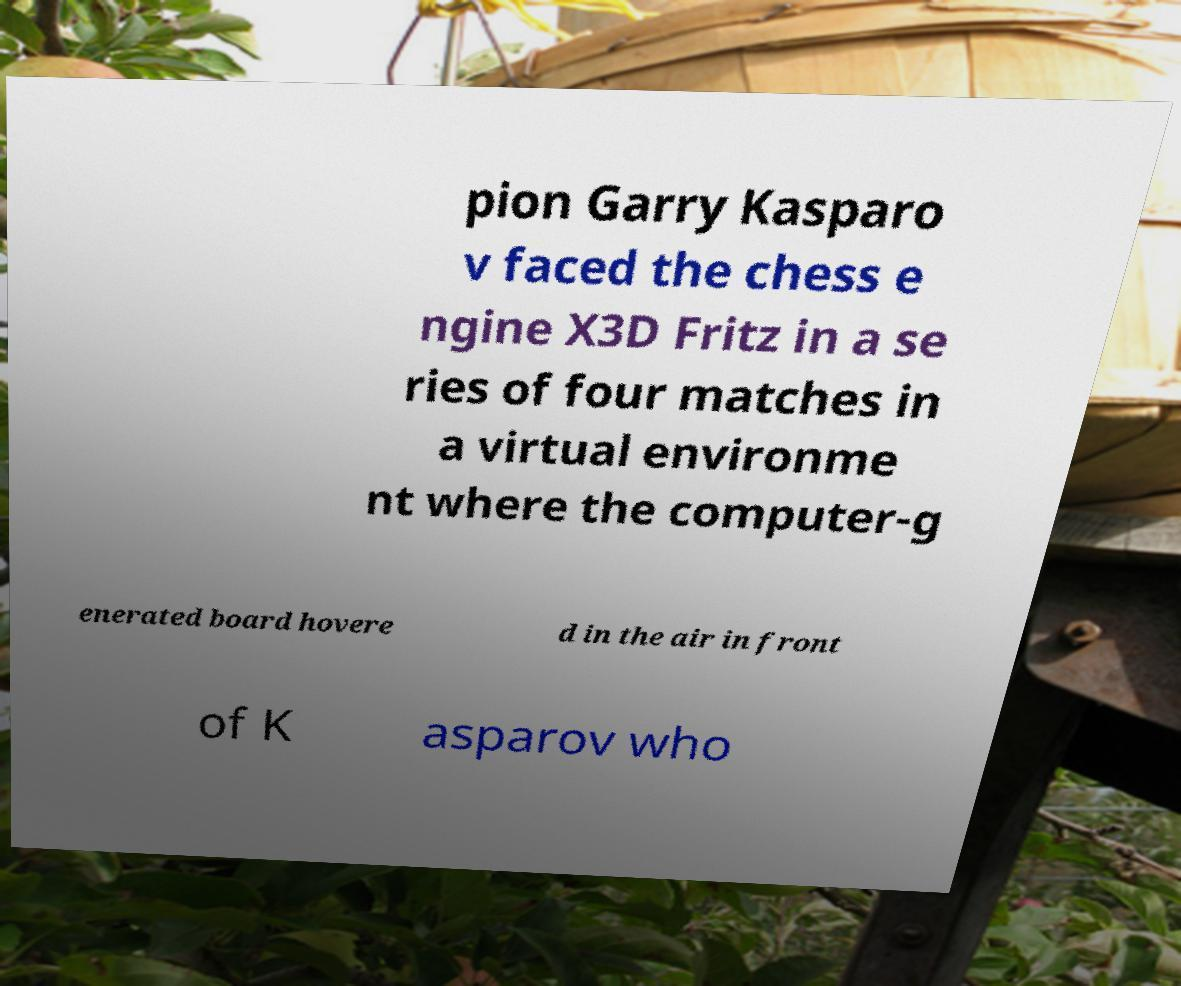Can you read and provide the text displayed in the image?This photo seems to have some interesting text. Can you extract and type it out for me? pion Garry Kasparo v faced the chess e ngine X3D Fritz in a se ries of four matches in a virtual environme nt where the computer-g enerated board hovere d in the air in front of K asparov who 